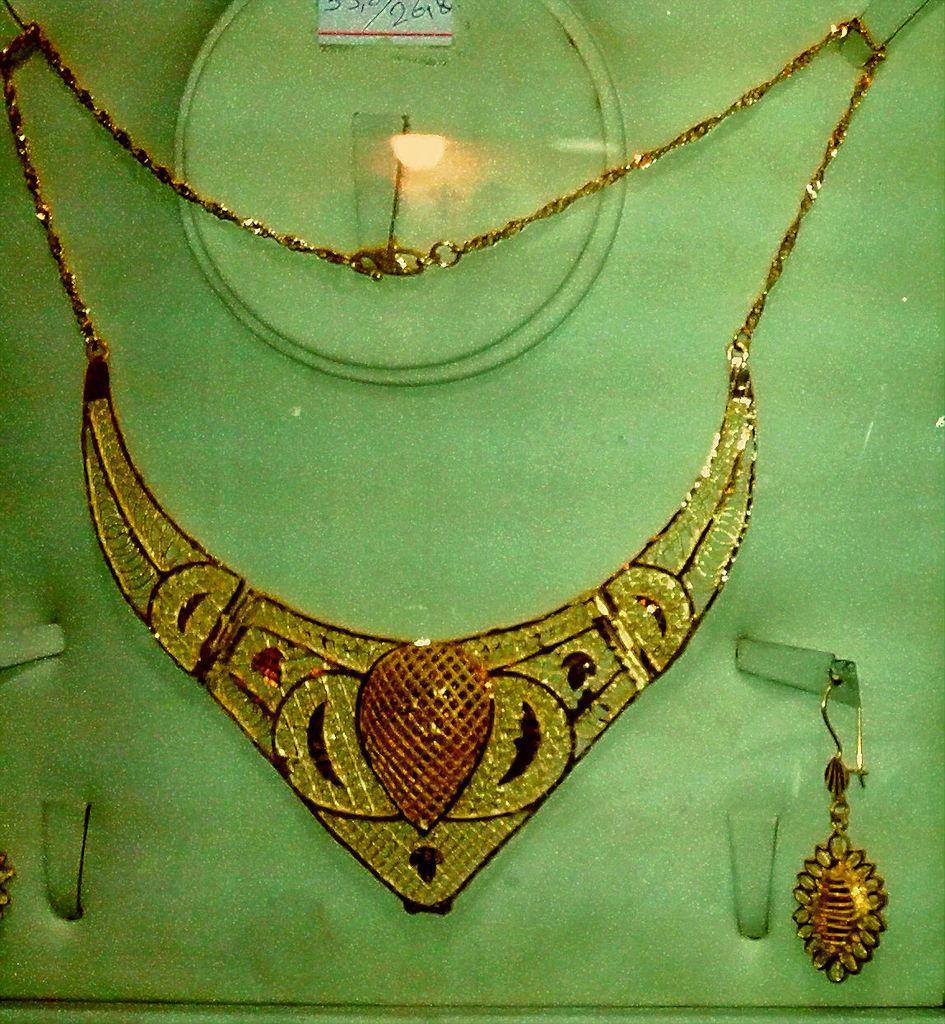Describe this image in one or two sentences. In this picture we can see ornaments and a sticker on the surface. 